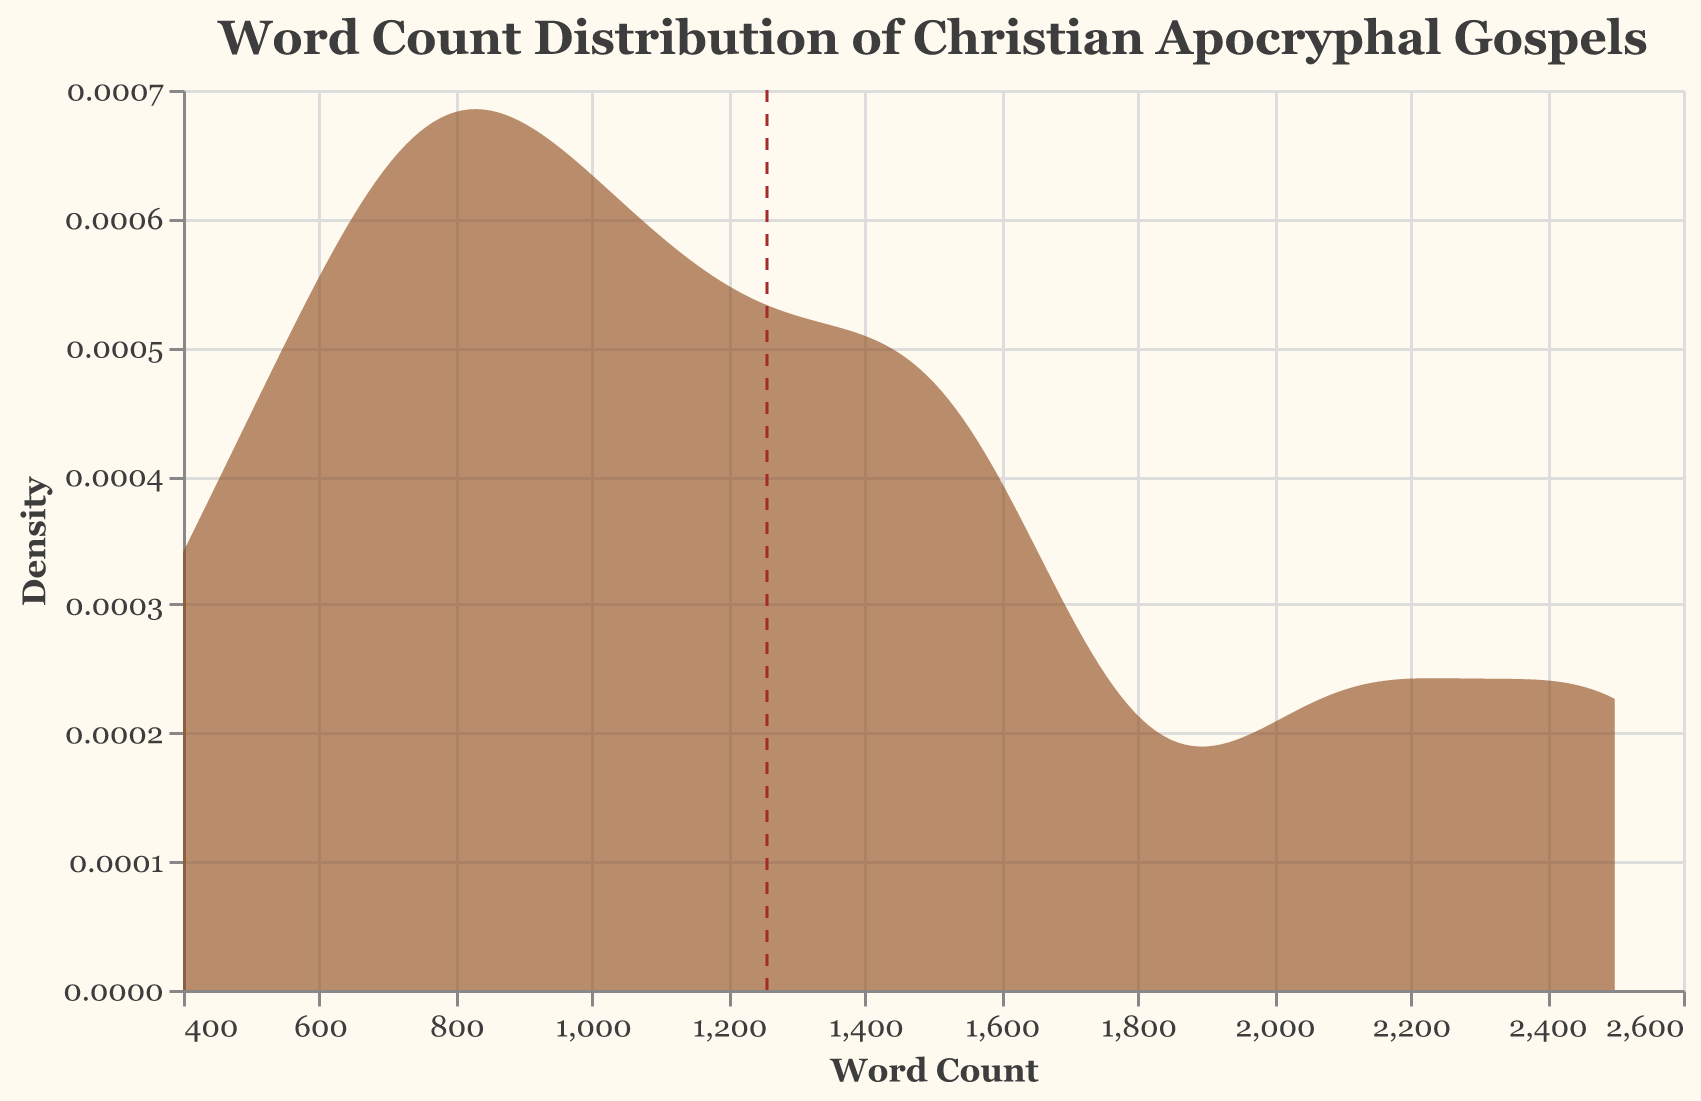What is the title of the plot? The title is displayed at the top of the plot. It reads: "Word Count Distribution of Christian Apocryphal Gospels."
Answer: Word Count Distribution of Christian Apocryphal Gospels What is the color and opacity of the density area mark? The density area mark is filled with a color and given a certain opacity. According to the visual information, the color is a shade of brown and appears semi-transparent.
Answer: Brown, 0.6 opacity What does the x-axis represent? The label and units on the x-axis show what is being measured. In this plot, the x-axis is labeled "Word Count," which indicates it represents the word count of the gospels.
Answer: Word Count What is the approximate mean word count of the gospels? The mean word count is indicated by a vertical dashed line on the plot. Observing the location of this line helps determine the mean value.
Answer: ~1250 Which gospel has the highest word count? To find the highest word count, compare the word counts of each gospel provided in the dataset. The Infancy Gospel of James has the highest word count, as it is noted to have 2500 words.
Answer: Infancy Gospel of James Compare the density around word count values of 800 and 2100. Which has a higher density? Observing the density curves, one can compare the y-values (density) at the specified x-values (word counts). The region around 800 has a lower peak than the region around 2100.
Answer: 2100 What is the number of gospels having word counts greater than 1000 but less than 2000? To answer this, count the gospels from the dataset whose word counts fall within the specified range: 1200 (Peter), 1465 (Thomas), 1560 (Judas), and 1060 (Philip).
Answer: 4 What does the y-axis represent? The y-axis label explains what is being measured on the vertical scale. In this plot, the y-axis is labeled "Density," showing it represents the density of word counts.
Answer: Density Based on the density plot, which range of word counts has the highest density? The highest density is observed at the highest peak of the density curve. This peak is around the lower 2000s.
Answer: Around 2000 words Is there any significant skewness visible in the word count distribution? By examining the density curve, one can determine if there is skewness. The plot shows a longer tail on the higher word count side, indicating positive skewness.
Answer: Yes, positive skewness 